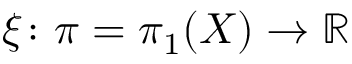<formula> <loc_0><loc_0><loc_500><loc_500>\xi \colon \pi = \pi _ { 1 } ( X ) \to \mathbb { R }</formula> 